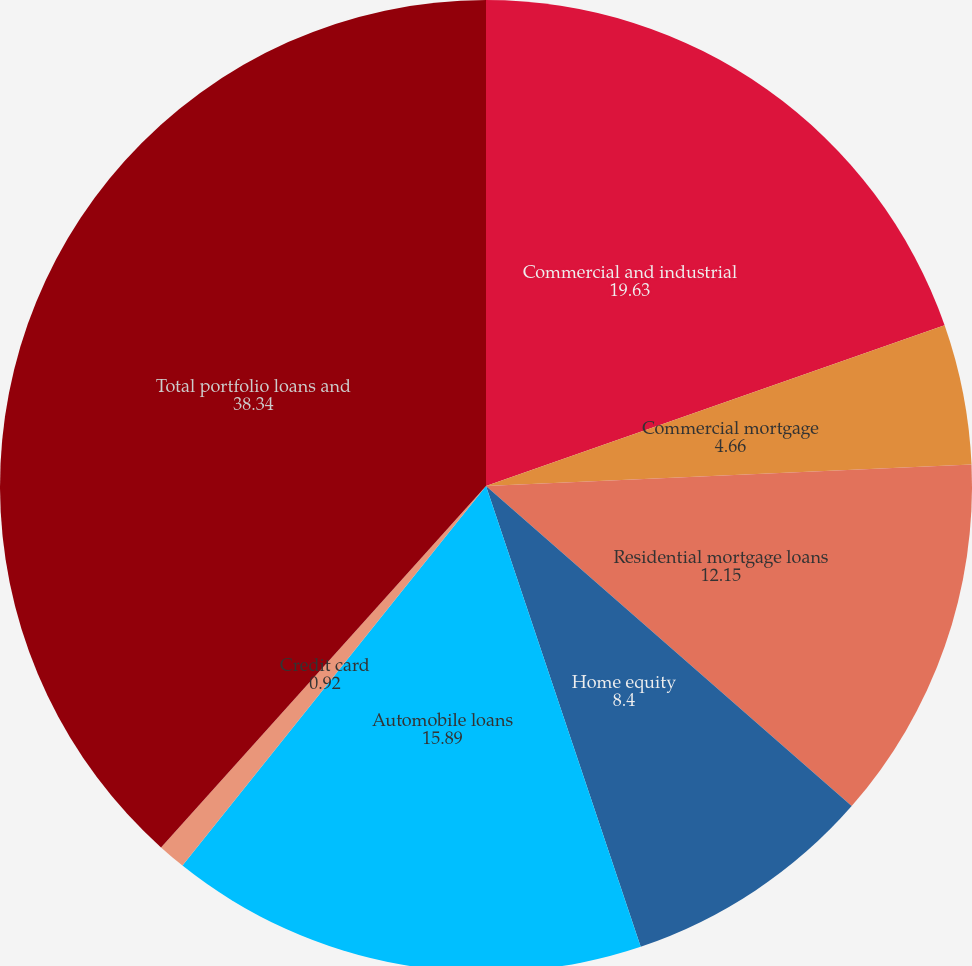Convert chart to OTSL. <chart><loc_0><loc_0><loc_500><loc_500><pie_chart><fcel>Commercial and industrial<fcel>Commercial mortgage<fcel>Residential mortgage loans<fcel>Home equity<fcel>Automobile loans<fcel>Credit card<fcel>Total portfolio loans and<nl><fcel>19.63%<fcel>4.66%<fcel>12.15%<fcel>8.4%<fcel>15.89%<fcel>0.92%<fcel>38.34%<nl></chart> 